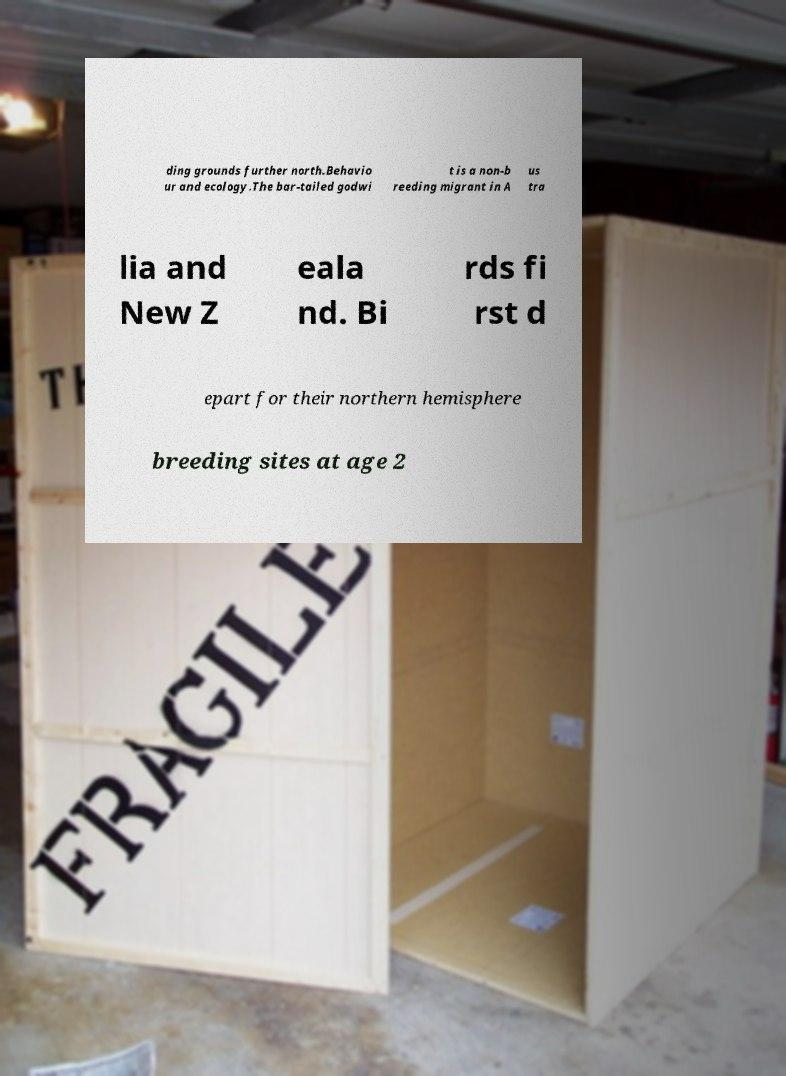What messages or text are displayed in this image? I need them in a readable, typed format. ding grounds further north.Behavio ur and ecology.The bar-tailed godwi t is a non-b reeding migrant in A us tra lia and New Z eala nd. Bi rds fi rst d epart for their northern hemisphere breeding sites at age 2 